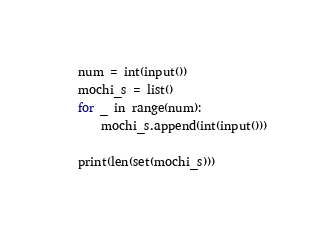Convert code to text. <code><loc_0><loc_0><loc_500><loc_500><_Python_>num = int(input())
mochi_s = list()
for _ in range(num):
    mochi_s.append(int(input()))

print(len(set(mochi_s)))</code> 